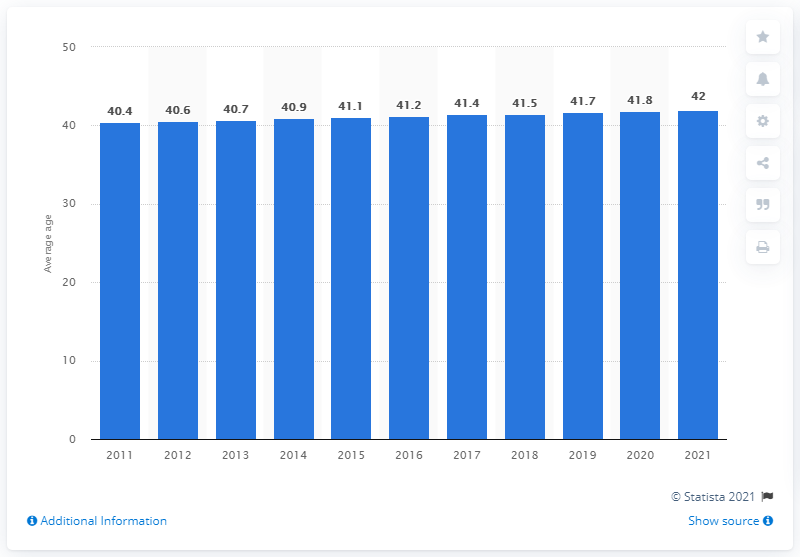Give some essential details in this illustration. The average age of the Danish population increased to 2021, which was not the case in 2011. 